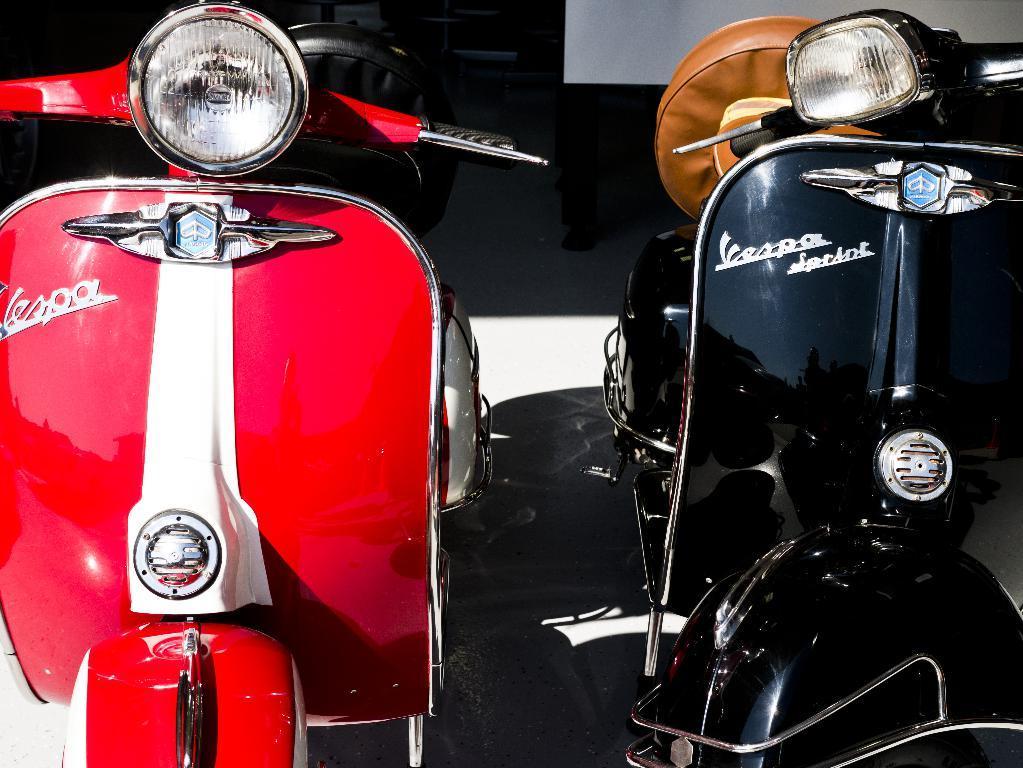Please provide a concise description of this image. In this image we can see there are two bikes parked. 